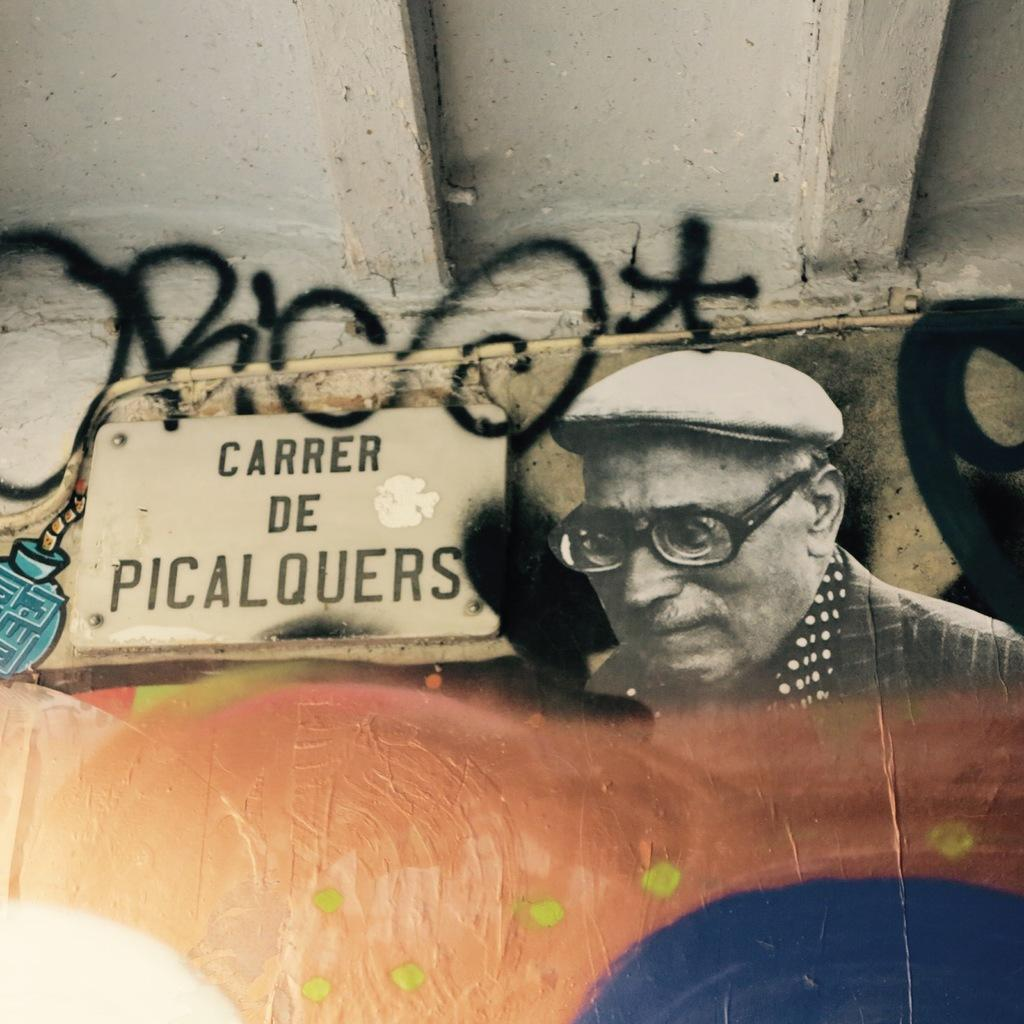What type of artwork is on the wall in the image? There is a wooden painting on the wall in the image. What part of a building can be seen at the top of the image? The roof is visible at the top of the image. What is attached to the wall in the image? There is a pipe on the wall in the image. What type of root can be seen growing in the middle of the image? There is no root visible in the image; it features a wooden painting, a roof, and a pipe on the wall. 